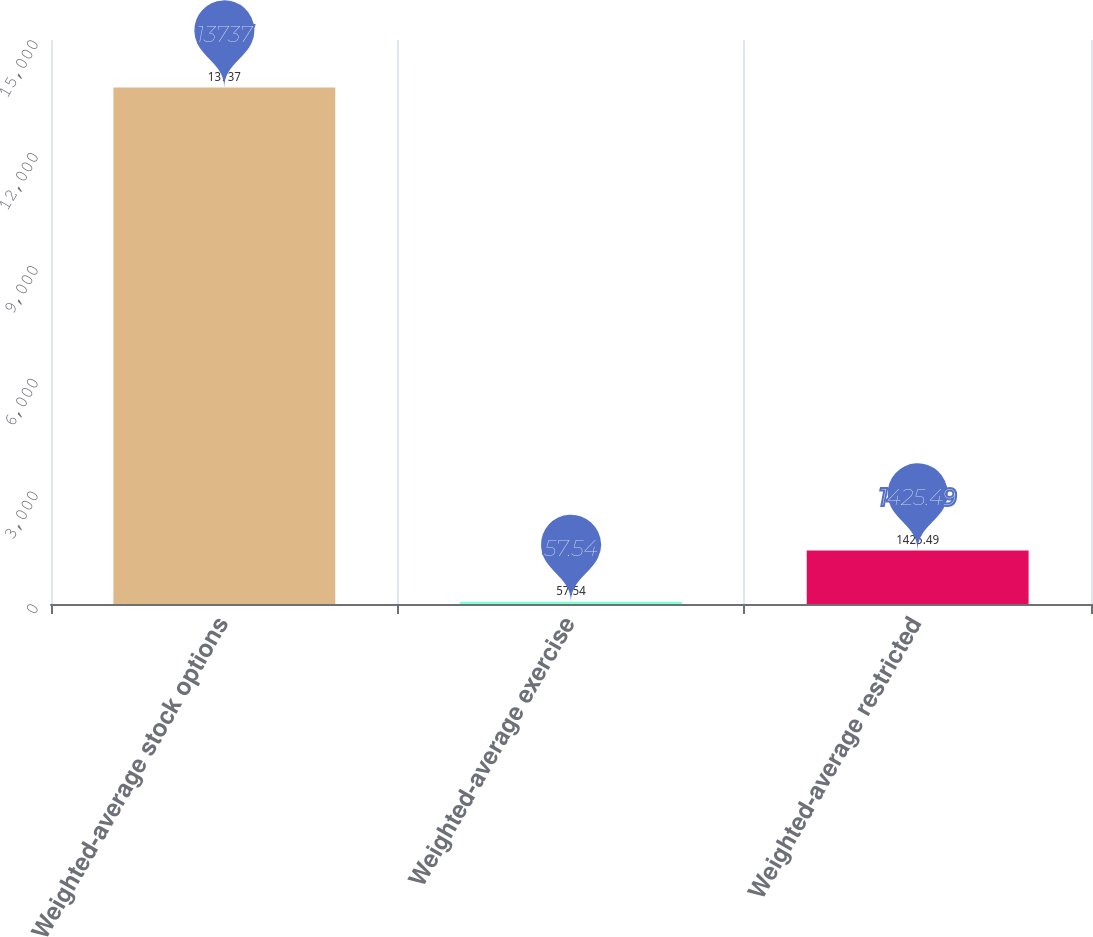Convert chart. <chart><loc_0><loc_0><loc_500><loc_500><bar_chart><fcel>Weighted-average stock options<fcel>Weighted-average exercise<fcel>Weighted-average restricted<nl><fcel>13737<fcel>57.54<fcel>1425.49<nl></chart> 